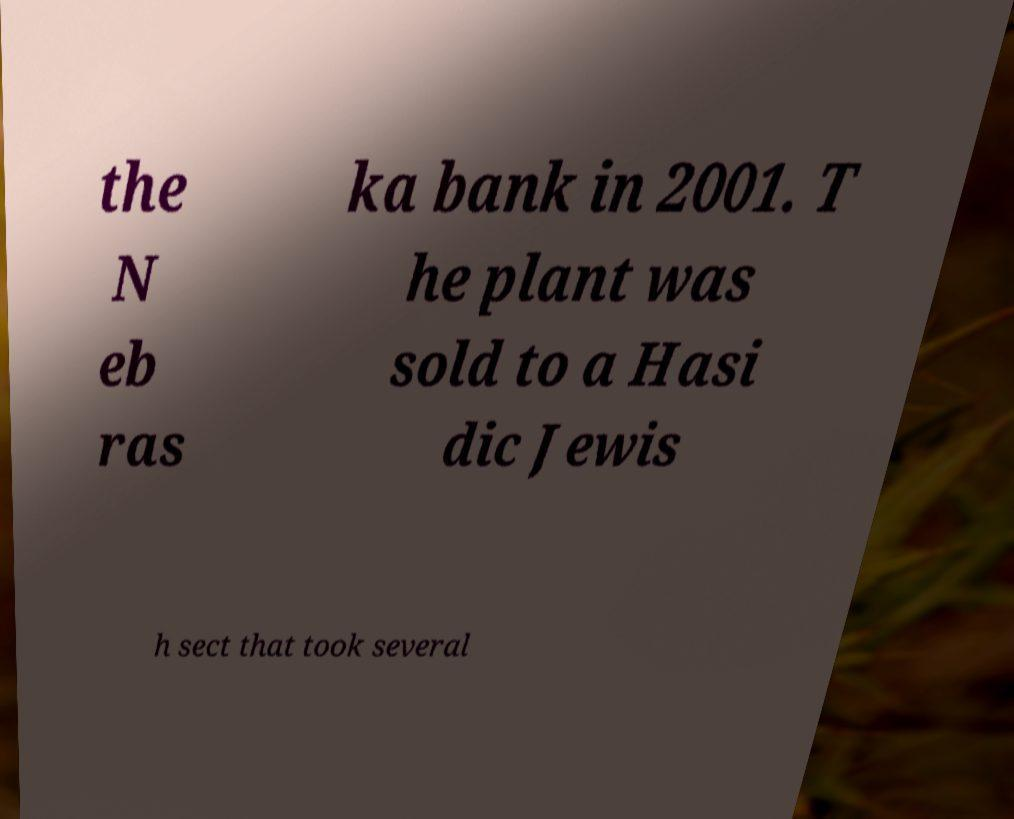Please read and relay the text visible in this image. What does it say? the N eb ras ka bank in 2001. T he plant was sold to a Hasi dic Jewis h sect that took several 